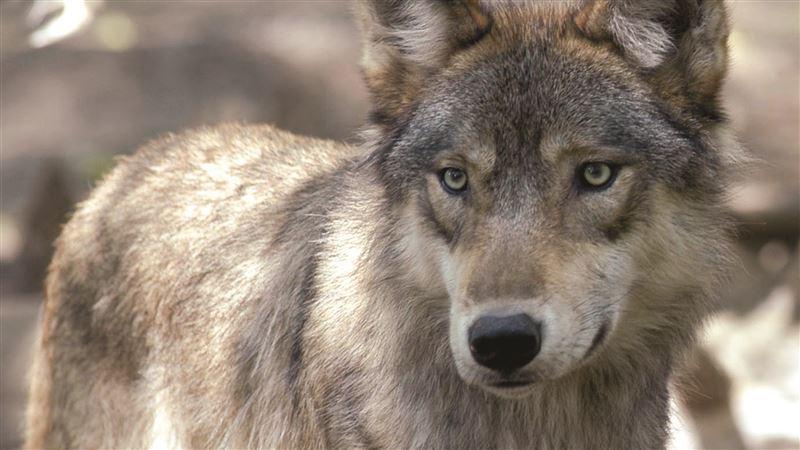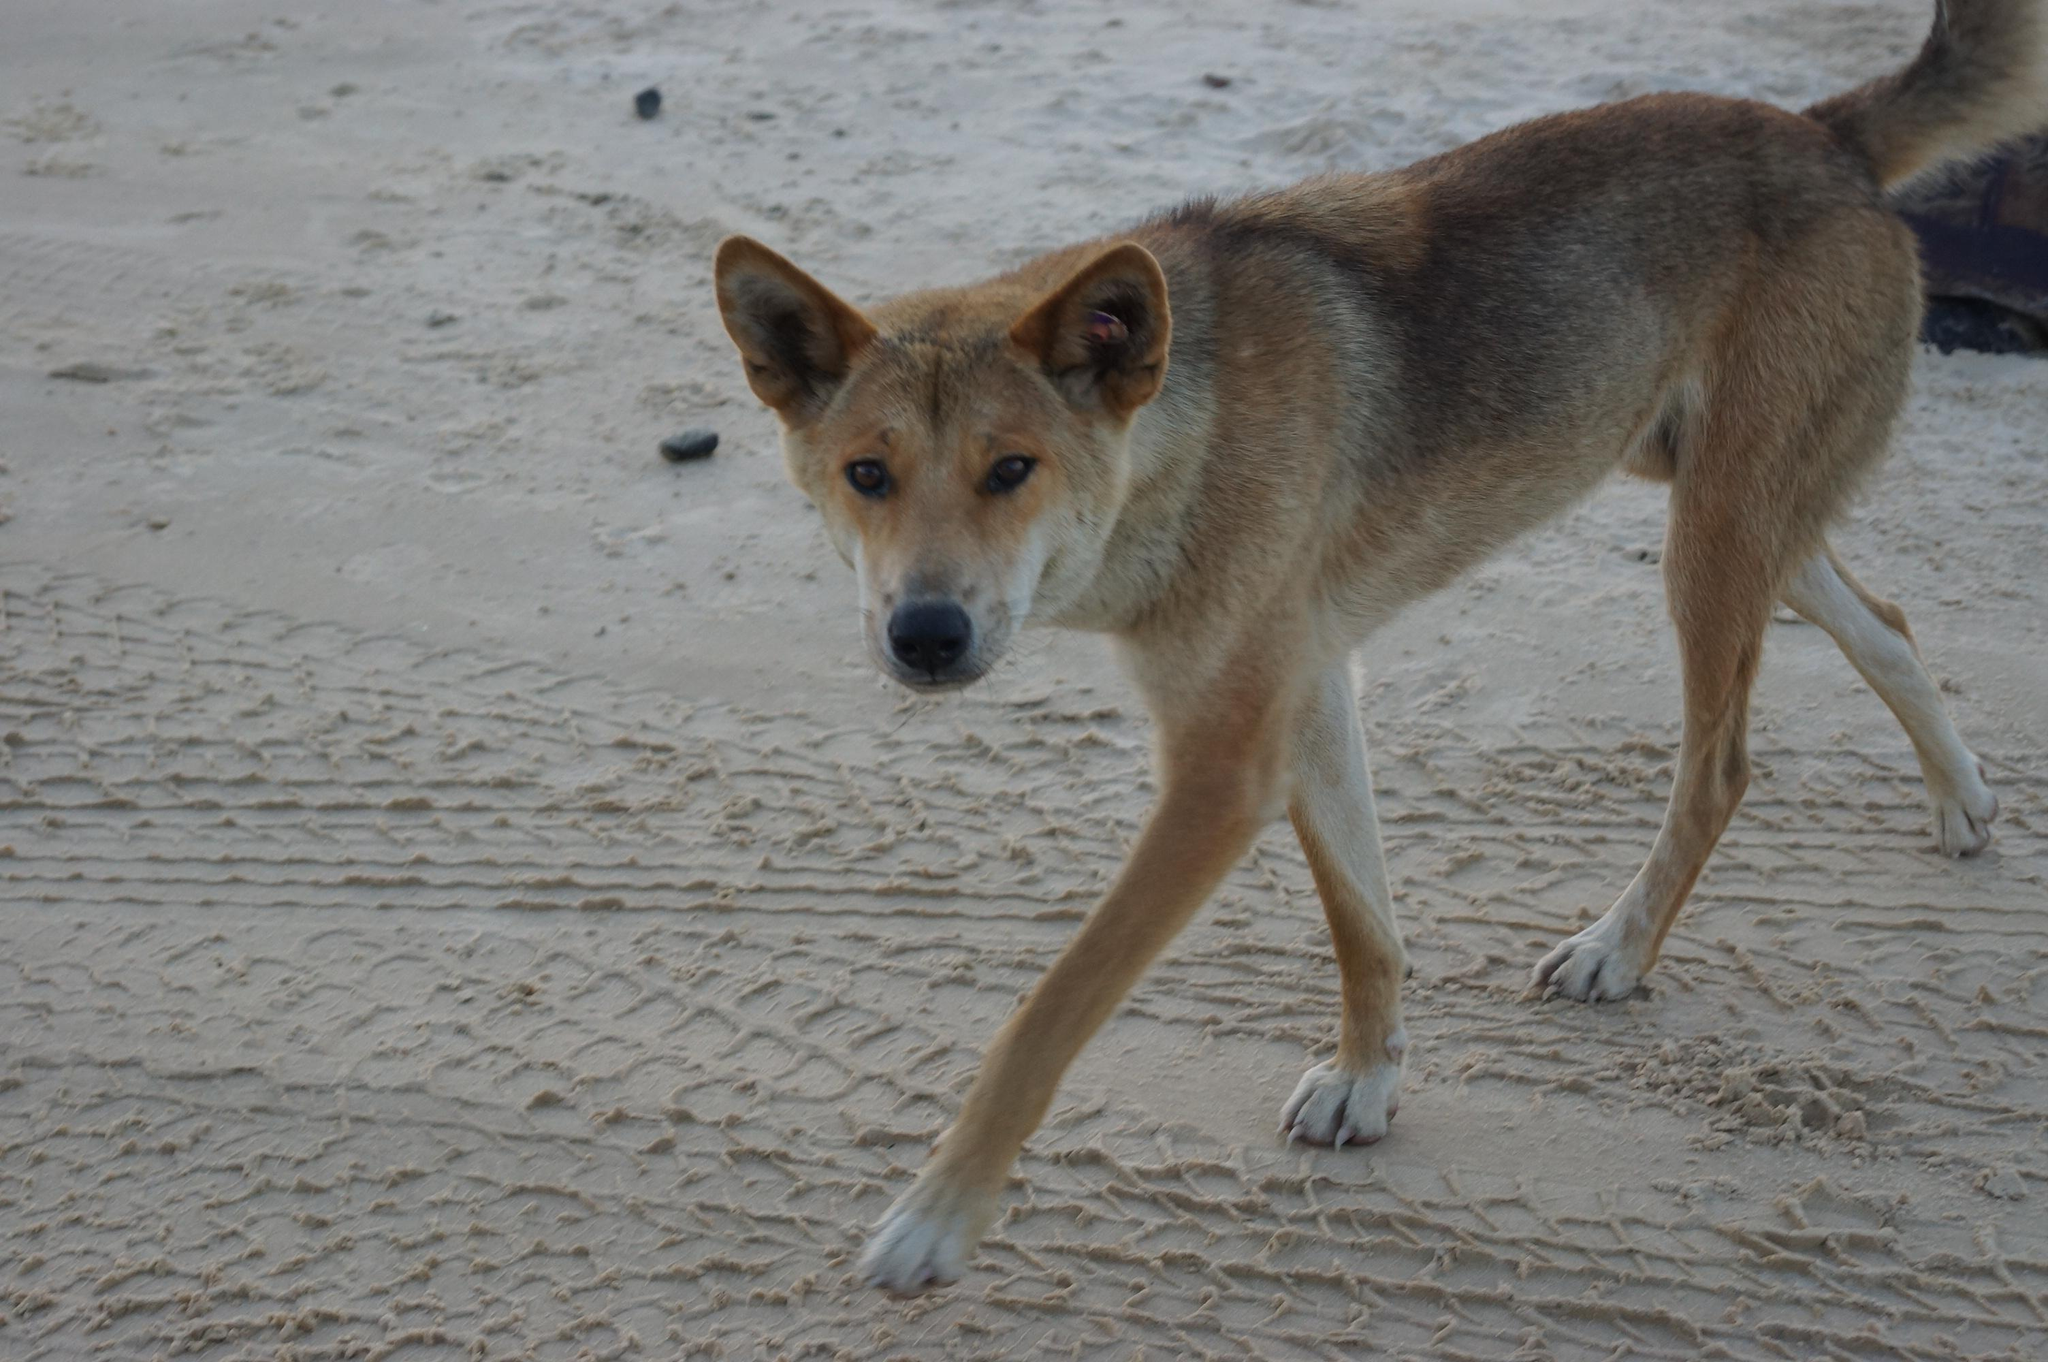The first image is the image on the left, the second image is the image on the right. Examine the images to the left and right. Is the description "The dog in the image on the left is laying down on the ground." accurate? Answer yes or no. No. The first image is the image on the left, the second image is the image on the right. Analyze the images presented: Is the assertion "The left image features one reclining orange dog, and the right image includes at least one standing orange puppy." valid? Answer yes or no. No. 